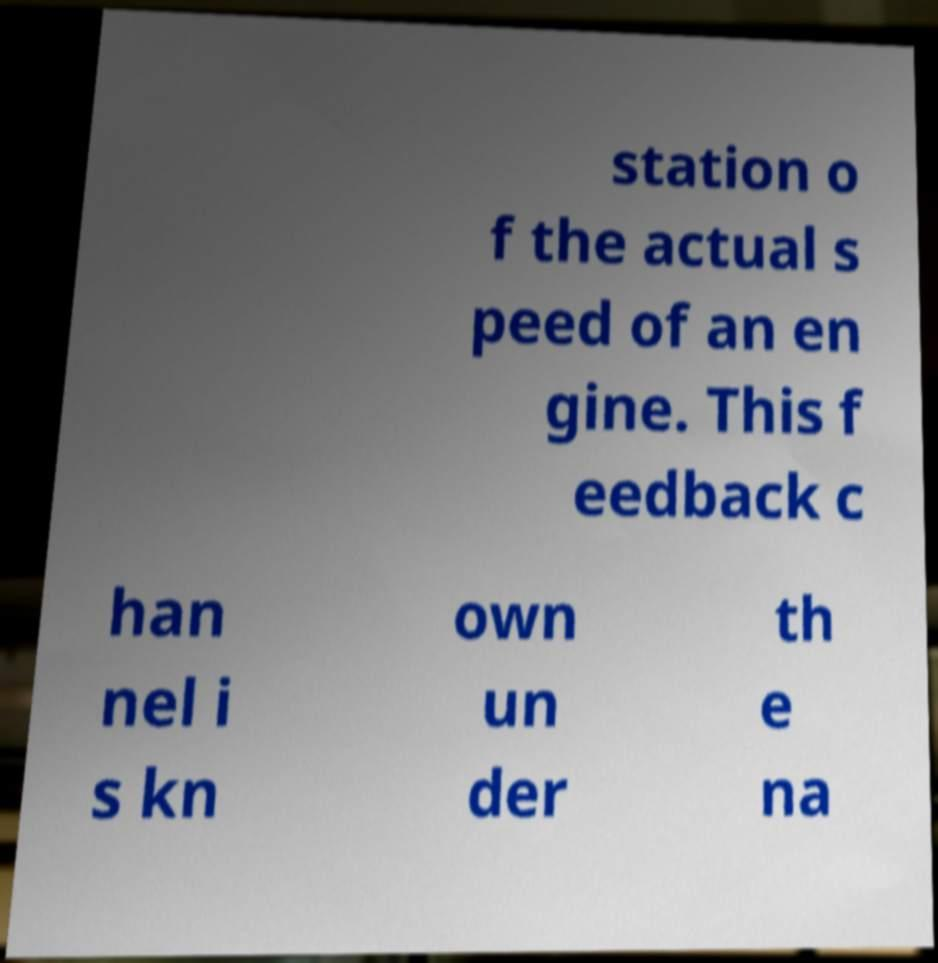Please read and relay the text visible in this image. What does it say? station o f the actual s peed of an en gine. This f eedback c han nel i s kn own un der th e na 